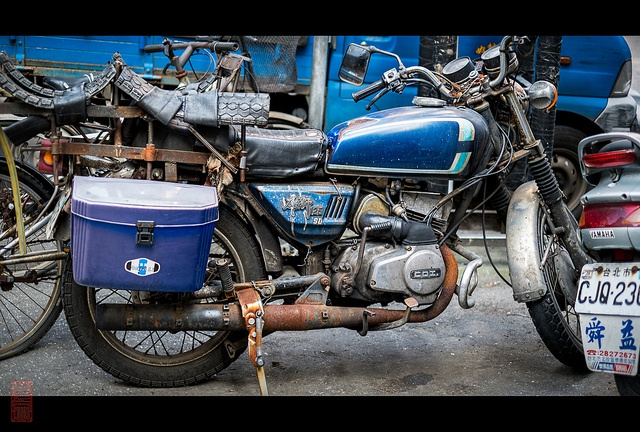Describe the objects in this image and their specific colors. I can see motorcycle in black, gray, darkgray, and lightgray tones, truck in black, blue, navy, and gray tones, and motorcycle in black, lightgray, darkgray, and gray tones in this image. 